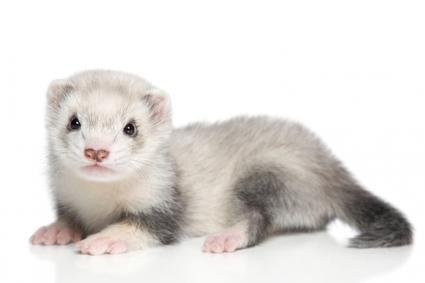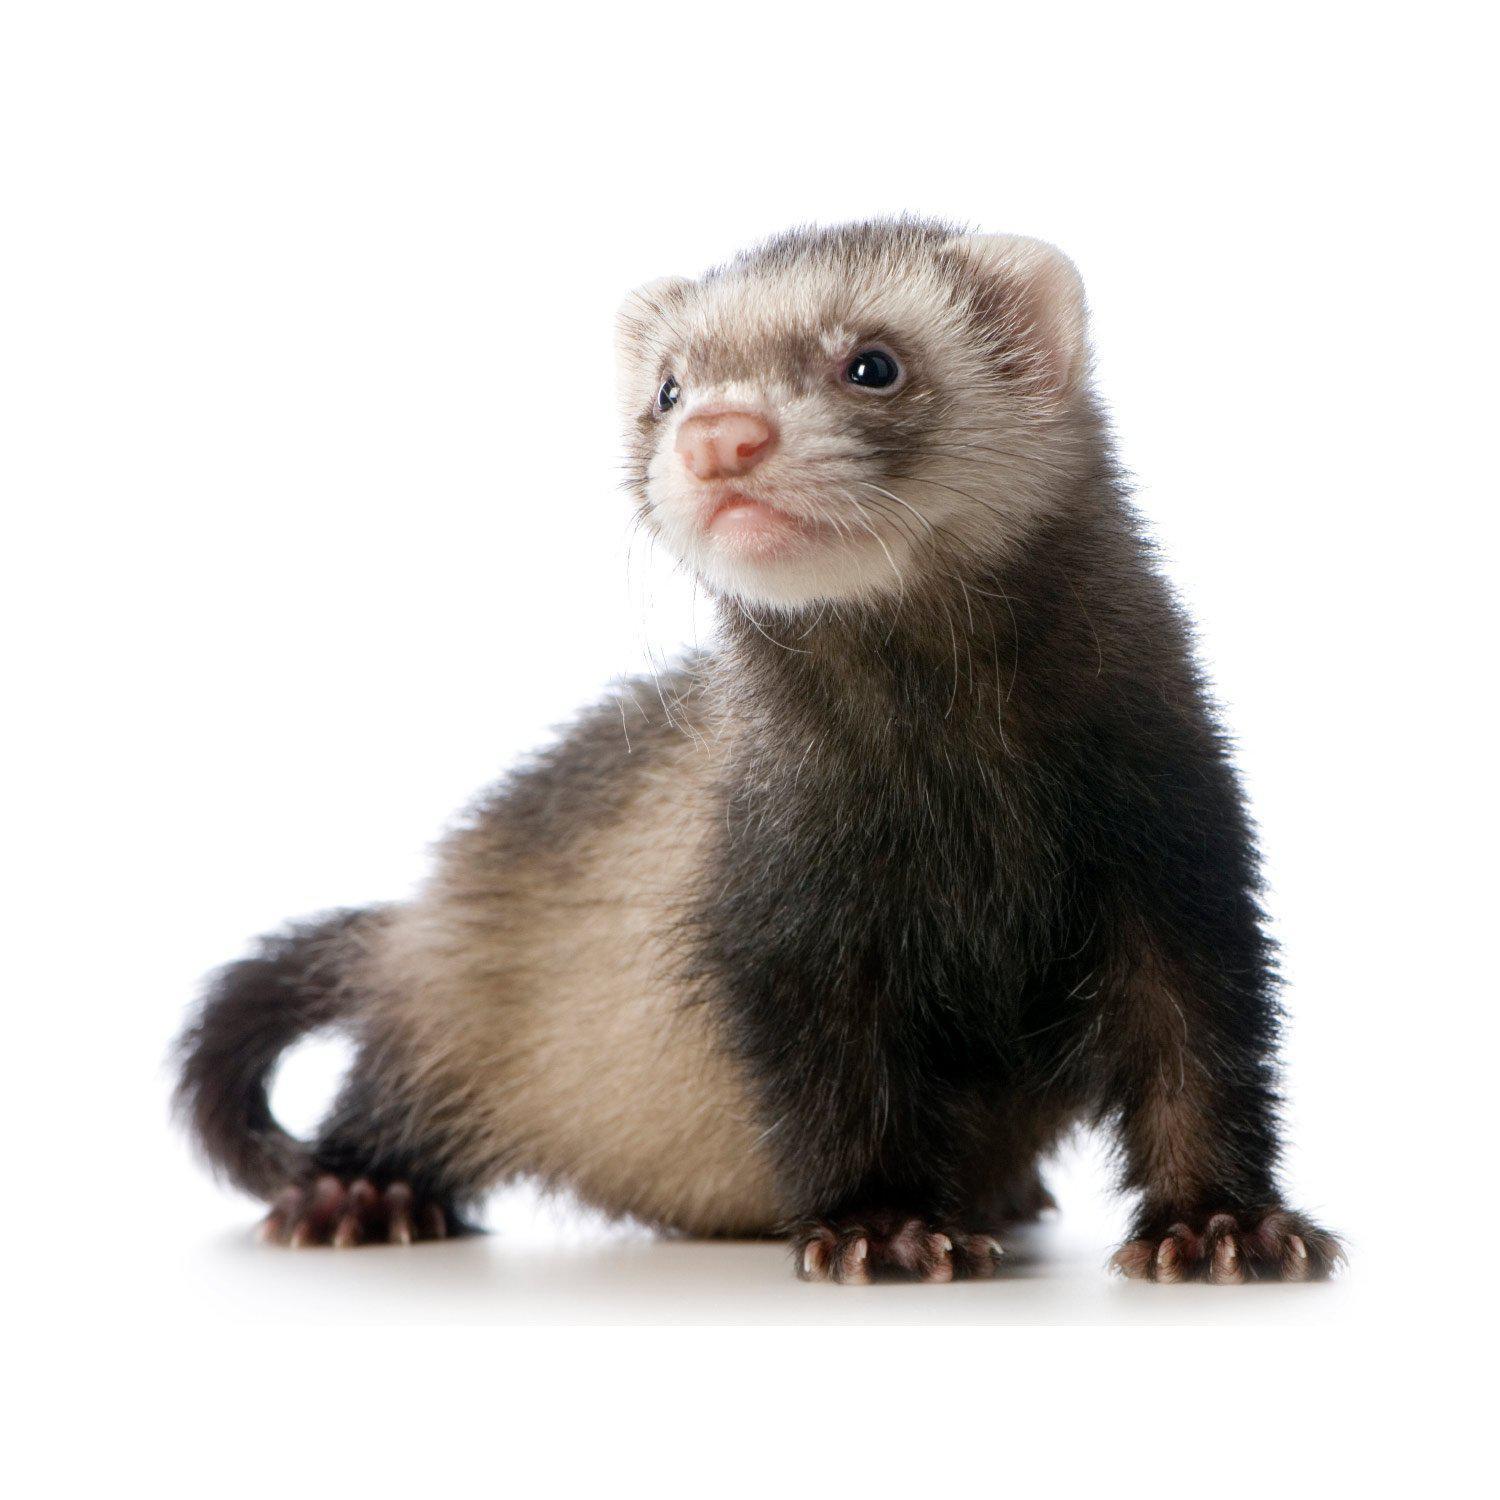The first image is the image on the left, the second image is the image on the right. Evaluate the accuracy of this statement regarding the images: "There are two animals in the image on the right.". Is it true? Answer yes or no. No. 